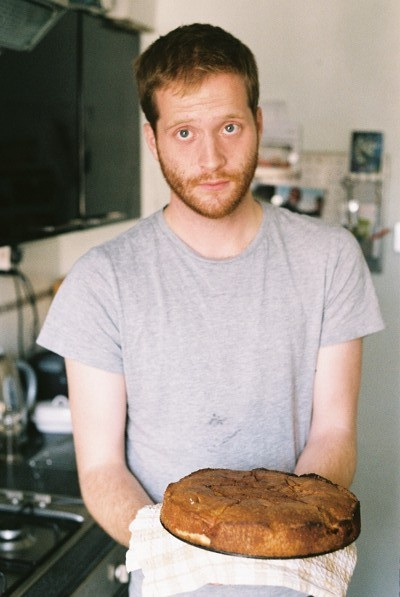Describe the objects in this image and their specific colors. I can see people in black, lightgray, tan, and darkgray tones, cake in black, brown, maroon, and orange tones, and oven in black, gray, and darkgreen tones in this image. 